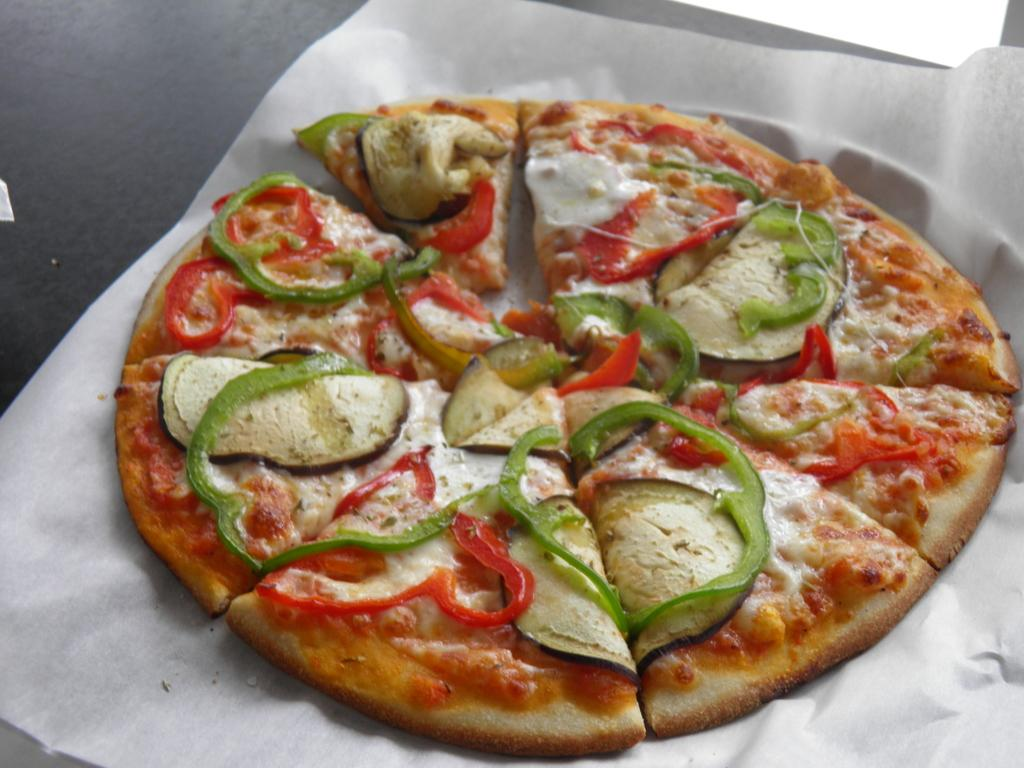What type of food is visible in the image? There is pizza in the image. Where is the pizza located? The pizza is placed on a table. What is the doll's interest in the division of the pizza? There is no doll present in the image, and therefore no information about its interest in the division of the pizza. 